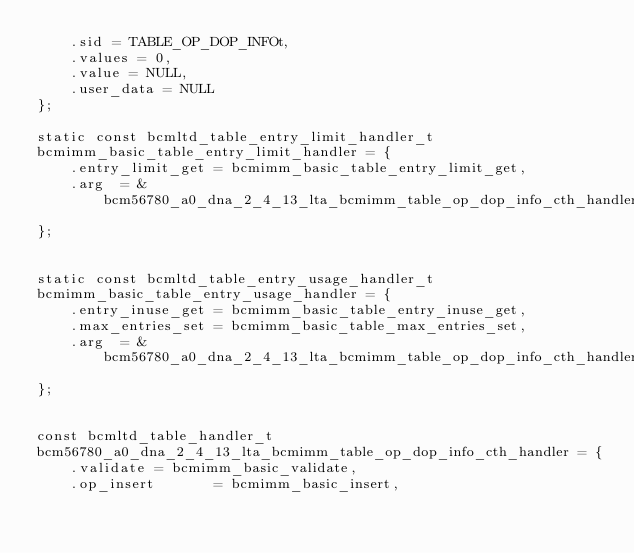Convert code to text. <code><loc_0><loc_0><loc_500><loc_500><_C_>    .sid = TABLE_OP_DOP_INFOt,
    .values = 0,
    .value = NULL,
    .user_data = NULL
};

static const bcmltd_table_entry_limit_handler_t
bcmimm_basic_table_entry_limit_handler = {
    .entry_limit_get = bcmimm_basic_table_entry_limit_get,
    .arg  = &bcm56780_a0_dna_2_4_13_lta_bcmimm_table_op_dop_info_cth_handler_arg
};


static const bcmltd_table_entry_usage_handler_t
bcmimm_basic_table_entry_usage_handler = {
    .entry_inuse_get = bcmimm_basic_table_entry_inuse_get,
    .max_entries_set = bcmimm_basic_table_max_entries_set,
    .arg  = &bcm56780_a0_dna_2_4_13_lta_bcmimm_table_op_dop_info_cth_handler_arg
};


const bcmltd_table_handler_t
bcm56780_a0_dna_2_4_13_lta_bcmimm_table_op_dop_info_cth_handler = {
    .validate = bcmimm_basic_validate,
    .op_insert       = bcmimm_basic_insert,</code> 